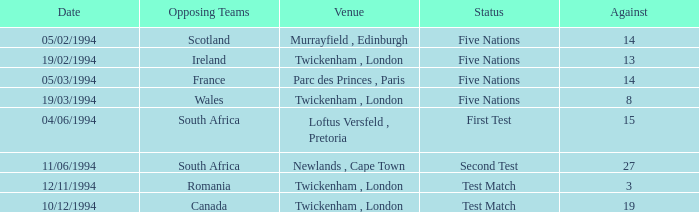How many against have a status of first test? 1.0. 